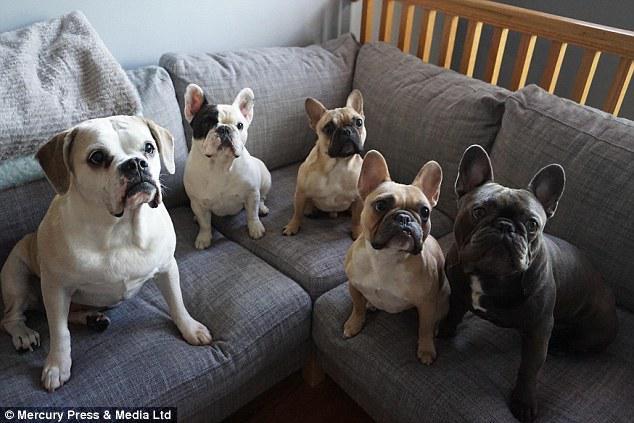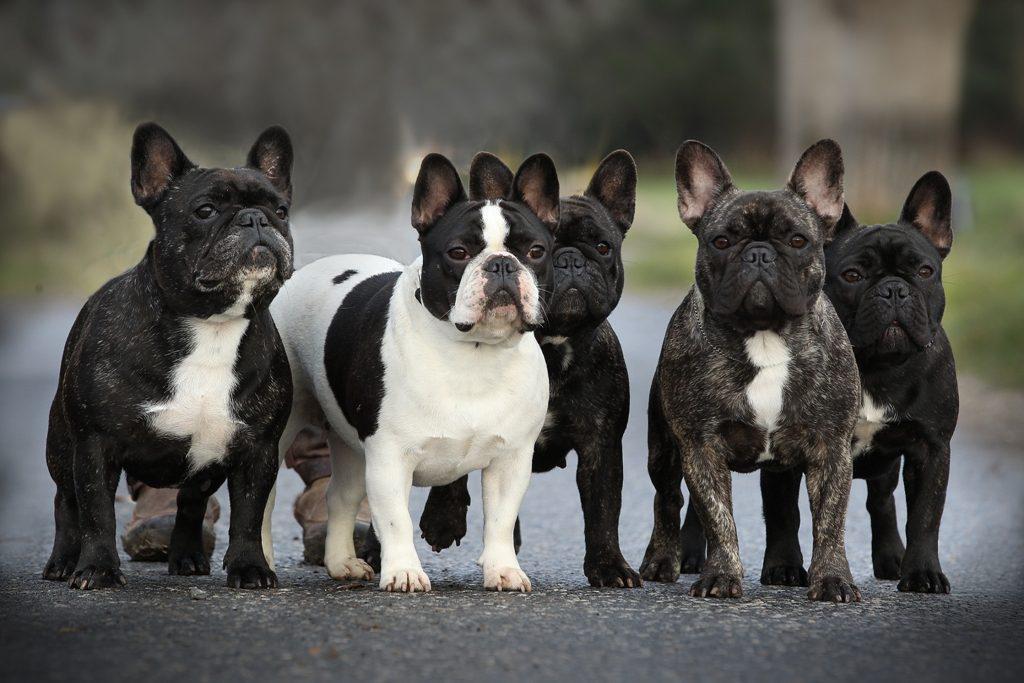The first image is the image on the left, the second image is the image on the right. Assess this claim about the two images: "At least one of the images features dogs that are outside.". Correct or not? Answer yes or no. Yes. The first image is the image on the left, the second image is the image on the right. Given the left and right images, does the statement "There are five puppies in the right image." hold true? Answer yes or no. Yes. 